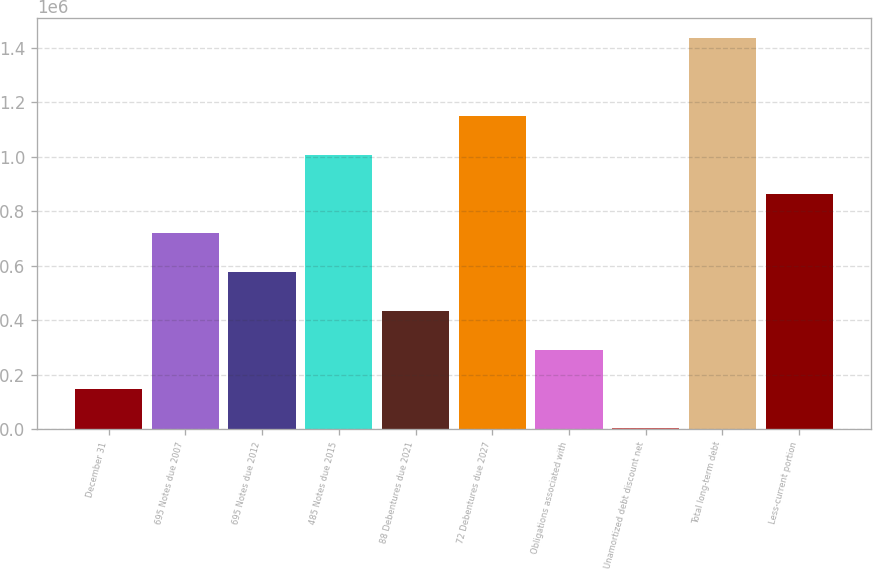Convert chart to OTSL. <chart><loc_0><loc_0><loc_500><loc_500><bar_chart><fcel>December 31<fcel>695 Notes due 2007<fcel>695 Notes due 2012<fcel>485 Notes due 2015<fcel>88 Debentures due 2021<fcel>72 Debentures due 2027<fcel>Obligations associated with<fcel>Unamortized debt discount net<fcel>Total long-term debt<fcel>Less-current portion<nl><fcel>145449<fcel>719424<fcel>575930<fcel>1.00641e+06<fcel>432436<fcel>1.14991e+06<fcel>288943<fcel>1955<fcel>1.43689e+06<fcel>862918<nl></chart> 